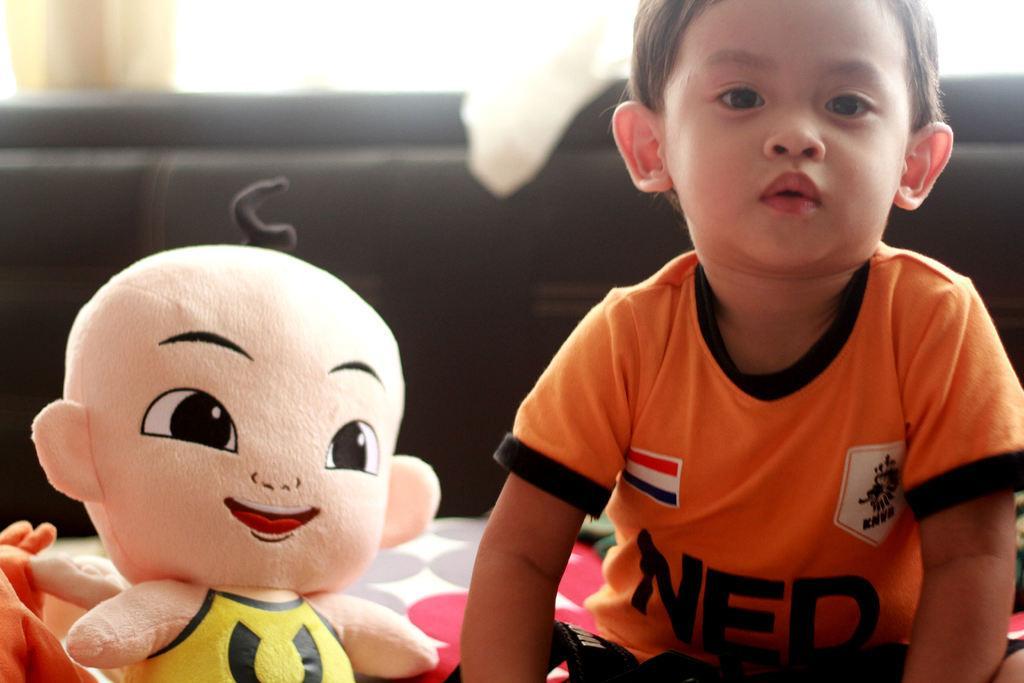How would you summarize this image in a sentence or two? In this image in the foreground there is one boy who is sitting beside him there is one toy ,and in the background there is a bed, window and curtains. 